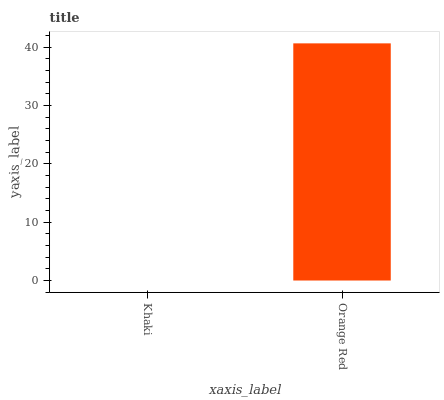Is Khaki the minimum?
Answer yes or no. Yes. Is Orange Red the maximum?
Answer yes or no. Yes. Is Orange Red the minimum?
Answer yes or no. No. Is Orange Red greater than Khaki?
Answer yes or no. Yes. Is Khaki less than Orange Red?
Answer yes or no. Yes. Is Khaki greater than Orange Red?
Answer yes or no. No. Is Orange Red less than Khaki?
Answer yes or no. No. Is Orange Red the high median?
Answer yes or no. Yes. Is Khaki the low median?
Answer yes or no. Yes. Is Khaki the high median?
Answer yes or no. No. Is Orange Red the low median?
Answer yes or no. No. 